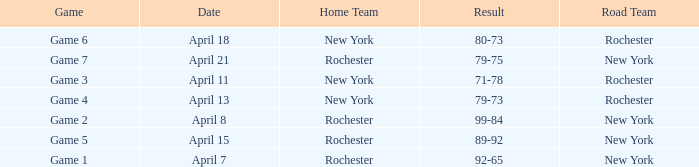Which Date has a Game of game 3? April 11. 